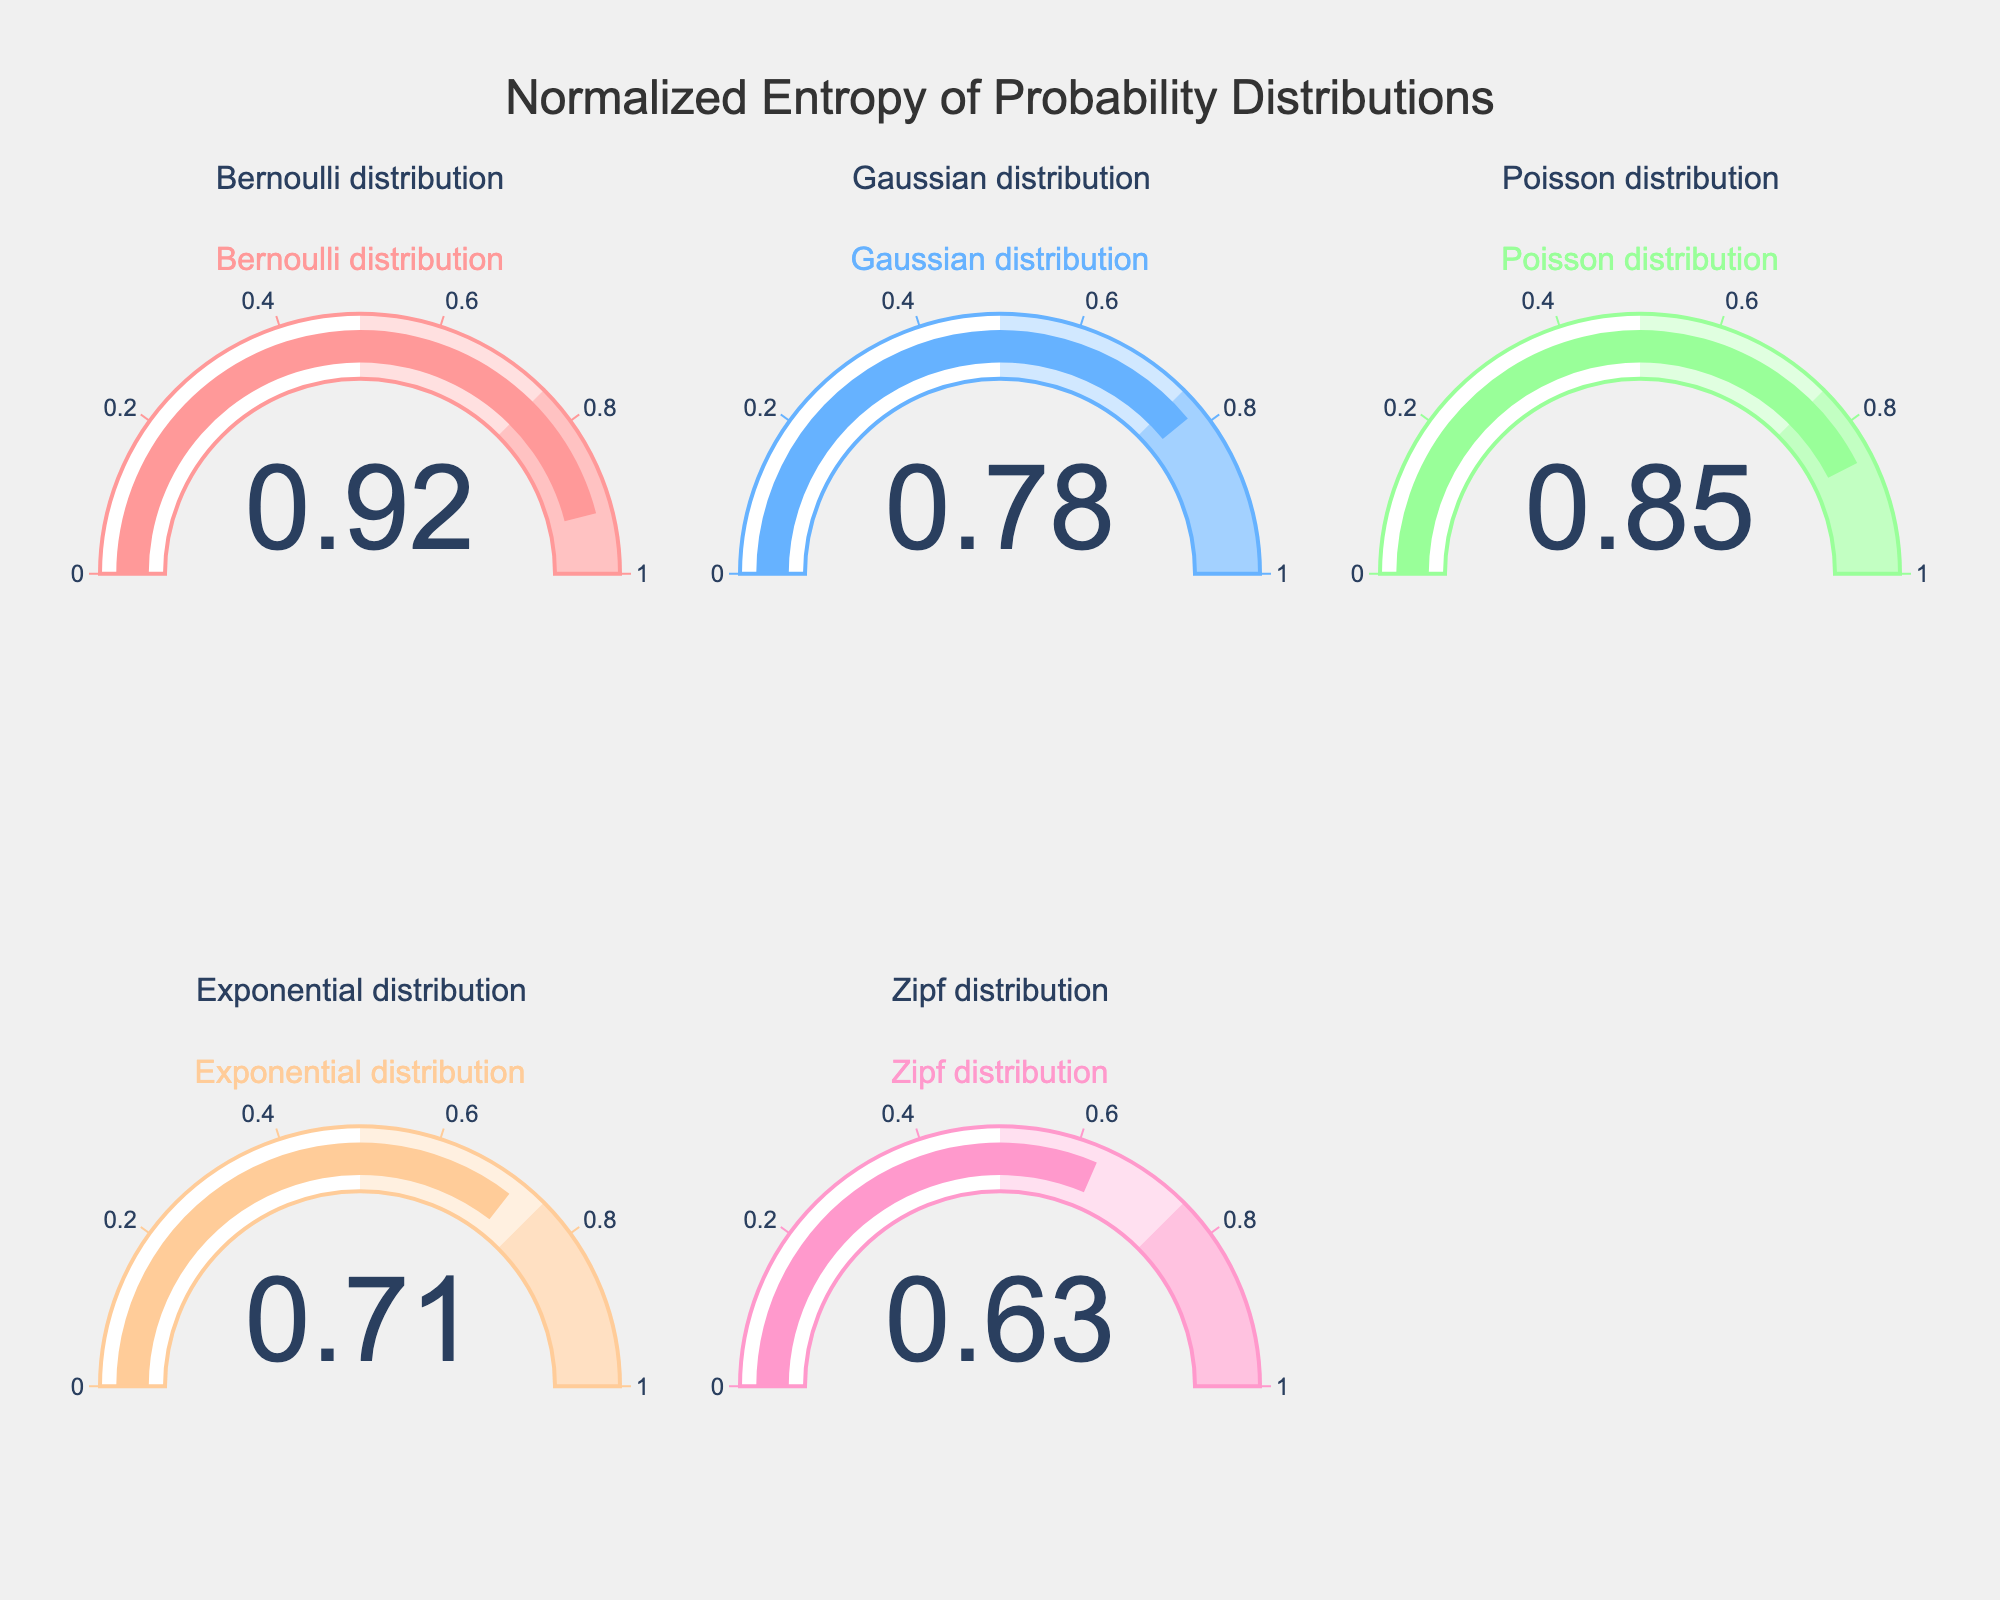What is the title of the chart? The title of the chart is located at the top center and reads: “Normalized Entropy of Probability Distributions”.
Answer: Normalized Entropy of Probability Distributions What is the normalized entropy of the Bernoulli distribution? The value is displayed on the gauge labeled “Bernoulli distribution” at the top left of the figure.
Answer: 0.92 Which distribution has the lowest normalized entropy? By examining all the gauges, the “Zipf distribution” has the lowest value displayed.
Answer: Zipf distribution What are the normalized entropy values for Gaussian and Poisson distributions? Check the gauges for the “Gaussian distribution” and “Poisson distribution”; the values are 0.78 and 0.85, respectively.
Answer: 0.78 and 0.85 Calculate the average normalized entropy of all distributions. Add all the normalized entropy values together (0.92 + 0.78 + 0.85 + 0.71 + 0.63) and then divide by the number of distributions (5). The calculation is (0.92 + 0.78 + 0.85 + 0.71 + 0.63) / 5 = 3.89 / 5 = 0.778.
Answer: 0.778 Which distributions have a normalized entropy greater than 0.75? The distributions with values greater than 0.75 are those with gauges showing values above this threshold: “Bernoulli distribution” (0.92), “Gaussian distribution” (0.78), and “Poisson distribution” (0.85).
Answer: Bernoulli, Gaussian, Poisson How much higher is the normalized entropy of the Bernoulli distribution compared to the Exponential distribution? Subtract the normalized entropy of the Exponential distribution (0.71) from that of the Bernoulli distribution (0.92): 0.92 - 0.71 = 0.21.
Answer: 0.21 Which distributions have normalized entropies between 0.7 and 0.9 inclusive? The distributions with entropies in this range are "Gaussian distribution" (0.78), "Poisson distribution" (0.85), and "Exponential distribution" (0.71).
Answer: Gaussian, Poisson, Exponential What is the difference in normalized entropy between the highest and the lowest values observed? The highest normalized entropy is 0.92 (Bernoulli distribution) and the lowest is 0.63 (Zipf distribution). The difference is 0.92 - 0.63 = 0.29.
Answer: 0.29 